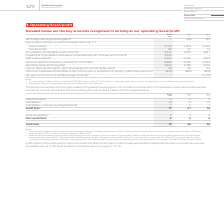From Vodafone Group Plc's financial document, Which financial years' information does this table show? The document contains multiple relevant values: 2017, 2018, 2019. From the document: "2019 2018 2017 €m €m €m Net foreign exchange losses/(gains) 1 1 (65) 133 Depreciation of property, plant and equip 2019 2018 2017 €m €m €m Net foreign..." Also, What is the last day of Vodafone's 2019 financial year? According to the financial document, 31 March. The relevant text states: "Notes: 1 The year ended 31 March 2019 included €nil (2018: €80 million credit, 2017: €127 million charge) reported in other income a..." Also, How much is the 2019 net foreign exchange losses? According to the financial document, 1 (in millions). The relevant text states: "2017 €m €m €m Net foreign exchange losses/(gains) 1 1 (65) 133 Depreciation of property, plant and equipment (note 11): Owned assets 5,795 5,963 6,253..." Additionally, Between 2018 and 2019, which year had a greater amount of owned assets? According to the financial document, 2018. The relevant text states: "2019 2018 2017 €m €m €m Net foreign exchange losses/(gains) 1 1 (65) 133 Depreciation of property, plant and..." Also, can you calculate: What is the average leased assets for 2018 and 2019? To answer this question, I need to perform calculations using the financial data. The calculation is: (47+59)/2, which equals 53 (in millions). This is based on the information: "11): Owned assets 5,795 5,963 6,253 Leased assets 59 47 12 Amortisation of intangible assets (note 10) 3,941 4,399 4,821 Impairment of goodwill in subsi : Owned assets 5,795 5,963 6,253 Leased assets ..." The key data points involved are: 47, 59. Also, can you calculate: What is the difference between the average owned assets and the average leased assets in 2018 and 2019? To answer this question, I need to perform calculations using the financial data. The calculation is: [(5,963+5,795)/2] - [(47+59)/2], which equals 5826 (in millions). This is based on the information: "11): Owned assets 5,795 5,963 6,253 Leased assets 59 47 12 Amortisation of intangible assets (note 10) 3,941 4,399 4,821 Impairment of goodwill in subsi plant and equipment (note 11): Owned assets 5,7..." The key data points involved are: 47, 5,795, 5,963. 